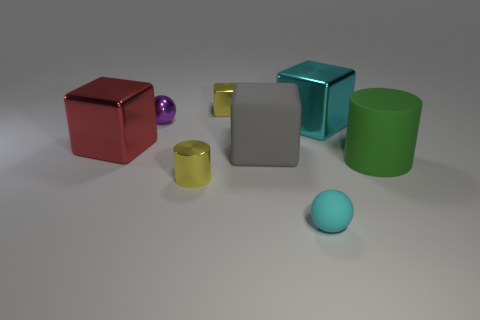Add 1 small brown matte balls. How many objects exist? 9 Subtract all balls. How many objects are left? 6 Subtract all yellow shiny cubes. Subtract all large purple metal cylinders. How many objects are left? 7 Add 3 rubber spheres. How many rubber spheres are left? 4 Add 7 yellow metal objects. How many yellow metal objects exist? 9 Subtract 0 brown cylinders. How many objects are left? 8 